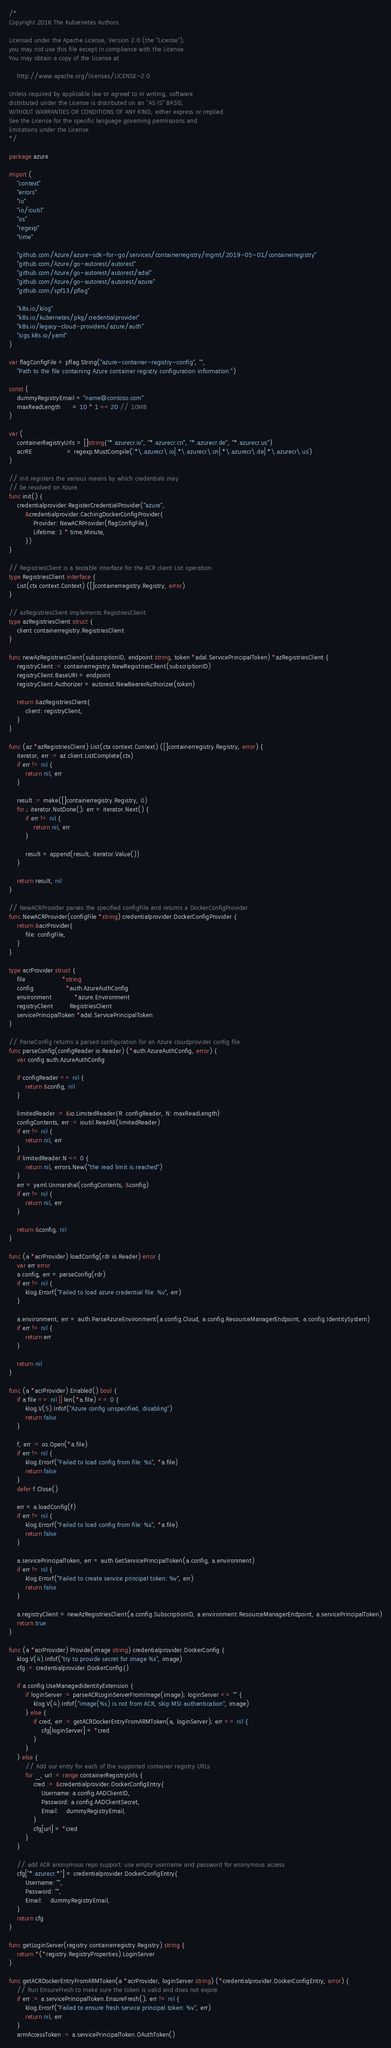<code> <loc_0><loc_0><loc_500><loc_500><_Go_>/*
Copyright 2016 The Kubernetes Authors.

Licensed under the Apache License, Version 2.0 (the "License");
you may not use this file except in compliance with the License.
You may obtain a copy of the License at

    http://www.apache.org/licenses/LICENSE-2.0

Unless required by applicable law or agreed to in writing, software
distributed under the License is distributed on an "AS IS" BASIS,
WITHOUT WARRANTIES OR CONDITIONS OF ANY KIND, either express or implied.
See the License for the specific language governing permissions and
limitations under the License.
*/

package azure

import (
	"context"
	"errors"
	"io"
	"io/ioutil"
	"os"
	"regexp"
	"time"

	"github.com/Azure/azure-sdk-for-go/services/containerregistry/mgmt/2019-05-01/containerregistry"
	"github.com/Azure/go-autorest/autorest"
	"github.com/Azure/go-autorest/autorest/adal"
	"github.com/Azure/go-autorest/autorest/azure"
	"github.com/spf13/pflag"

	"k8s.io/klog"
	"k8s.io/kubernetes/pkg/credentialprovider"
	"k8s.io/legacy-cloud-providers/azure/auth"
	"sigs.k8s.io/yaml"
)

var flagConfigFile = pflag.String("azure-container-registry-config", "",
	"Path to the file containing Azure container registry configuration information.")

const (
	dummyRegistryEmail = "name@contoso.com"
	maxReadLength      = 10 * 1 << 20 // 10MB
)

var (
	containerRegistryUrls = []string{"*.azurecr.io", "*.azurecr.cn", "*.azurecr.de", "*.azurecr.us"}
	acrRE                 = regexp.MustCompile(`.*\.azurecr\.io|.*\.azurecr\.cn|.*\.azurecr\.de|.*\.azurecr\.us`)
)

// init registers the various means by which credentials may
// be resolved on Azure.
func init() {
	credentialprovider.RegisterCredentialProvider("azure",
		&credentialprovider.CachingDockerConfigProvider{
			Provider: NewACRProvider(flagConfigFile),
			Lifetime: 1 * time.Minute,
		})
}

// RegistriesClient is a testable interface for the ACR client List operation.
type RegistriesClient interface {
	List(ctx context.Context) ([]containerregistry.Registry, error)
}

// azRegistriesClient implements RegistriesClient.
type azRegistriesClient struct {
	client containerregistry.RegistriesClient
}

func newAzRegistriesClient(subscriptionID, endpoint string, token *adal.ServicePrincipalToken) *azRegistriesClient {
	registryClient := containerregistry.NewRegistriesClient(subscriptionID)
	registryClient.BaseURI = endpoint
	registryClient.Authorizer = autorest.NewBearerAuthorizer(token)

	return &azRegistriesClient{
		client: registryClient,
	}
}

func (az *azRegistriesClient) List(ctx context.Context) ([]containerregistry.Registry, error) {
	iterator, err := az.client.ListComplete(ctx)
	if err != nil {
		return nil, err
	}

	result := make([]containerregistry.Registry, 0)
	for ; iterator.NotDone(); err = iterator.Next() {
		if err != nil {
			return nil, err
		}

		result = append(result, iterator.Value())
	}

	return result, nil
}

// NewACRProvider parses the specified configFile and returns a DockerConfigProvider
func NewACRProvider(configFile *string) credentialprovider.DockerConfigProvider {
	return &acrProvider{
		file: configFile,
	}
}

type acrProvider struct {
	file                  *string
	config                *auth.AzureAuthConfig
	environment           *azure.Environment
	registryClient        RegistriesClient
	servicePrincipalToken *adal.ServicePrincipalToken
}

// ParseConfig returns a parsed configuration for an Azure cloudprovider config file
func parseConfig(configReader io.Reader) (*auth.AzureAuthConfig, error) {
	var config auth.AzureAuthConfig

	if configReader == nil {
		return &config, nil
	}

	limitedReader := &io.LimitedReader{R: configReader, N: maxReadLength}
	configContents, err := ioutil.ReadAll(limitedReader)
	if err != nil {
		return nil, err
	}
	if limitedReader.N <= 0 {
		return nil, errors.New("the read limit is reached")
	}
	err = yaml.Unmarshal(configContents, &config)
	if err != nil {
		return nil, err
	}

	return &config, nil
}

func (a *acrProvider) loadConfig(rdr io.Reader) error {
	var err error
	a.config, err = parseConfig(rdr)
	if err != nil {
		klog.Errorf("Failed to load azure credential file: %v", err)
	}

	a.environment, err = auth.ParseAzureEnvironment(a.config.Cloud, a.config.ResourceManagerEndpoint, a.config.IdentitySystem)
	if err != nil {
		return err
	}

	return nil
}

func (a *acrProvider) Enabled() bool {
	if a.file == nil || len(*a.file) == 0 {
		klog.V(5).Infof("Azure config unspecified, disabling")
		return false
	}

	f, err := os.Open(*a.file)
	if err != nil {
		klog.Errorf("Failed to load config from file: %s", *a.file)
		return false
	}
	defer f.Close()

	err = a.loadConfig(f)
	if err != nil {
		klog.Errorf("Failed to load config from file: %s", *a.file)
		return false
	}

	a.servicePrincipalToken, err = auth.GetServicePrincipalToken(a.config, a.environment)
	if err != nil {
		klog.Errorf("Failed to create service principal token: %v", err)
		return false
	}

	a.registryClient = newAzRegistriesClient(a.config.SubscriptionID, a.environment.ResourceManagerEndpoint, a.servicePrincipalToken)
	return true
}

func (a *acrProvider) Provide(image string) credentialprovider.DockerConfig {
	klog.V(4).Infof("try to provide secret for image %s", image)
	cfg := credentialprovider.DockerConfig{}

	if a.config.UseManagedIdentityExtension {
		if loginServer := parseACRLoginServerFromImage(image); loginServer == "" {
			klog.V(4).Infof("image(%s) is not from ACR, skip MSI authentication", image)
		} else {
			if cred, err := getACRDockerEntryFromARMToken(a, loginServer); err == nil {
				cfg[loginServer] = *cred
			}
		}
	} else {
		// Add our entry for each of the supported container registry URLs
		for _, url := range containerRegistryUrls {
			cred := &credentialprovider.DockerConfigEntry{
				Username: a.config.AADClientID,
				Password: a.config.AADClientSecret,
				Email:    dummyRegistryEmail,
			}
			cfg[url] = *cred
		}
	}

	// add ACR anonymous repo support: use empty username and password for anonymous access
	cfg["*.azurecr.*"] = credentialprovider.DockerConfigEntry{
		Username: "",
		Password: "",
		Email:    dummyRegistryEmail,
	}
	return cfg
}

func getLoginServer(registry containerregistry.Registry) string {
	return *(*registry.RegistryProperties).LoginServer
}

func getACRDockerEntryFromARMToken(a *acrProvider, loginServer string) (*credentialprovider.DockerConfigEntry, error) {
	// Run EnsureFresh to make sure the token is valid and does not expire
	if err := a.servicePrincipalToken.EnsureFresh(); err != nil {
		klog.Errorf("Failed to ensure fresh service principal token: %v", err)
		return nil, err
	}
	armAccessToken := a.servicePrincipalToken.OAuthToken()
</code> 